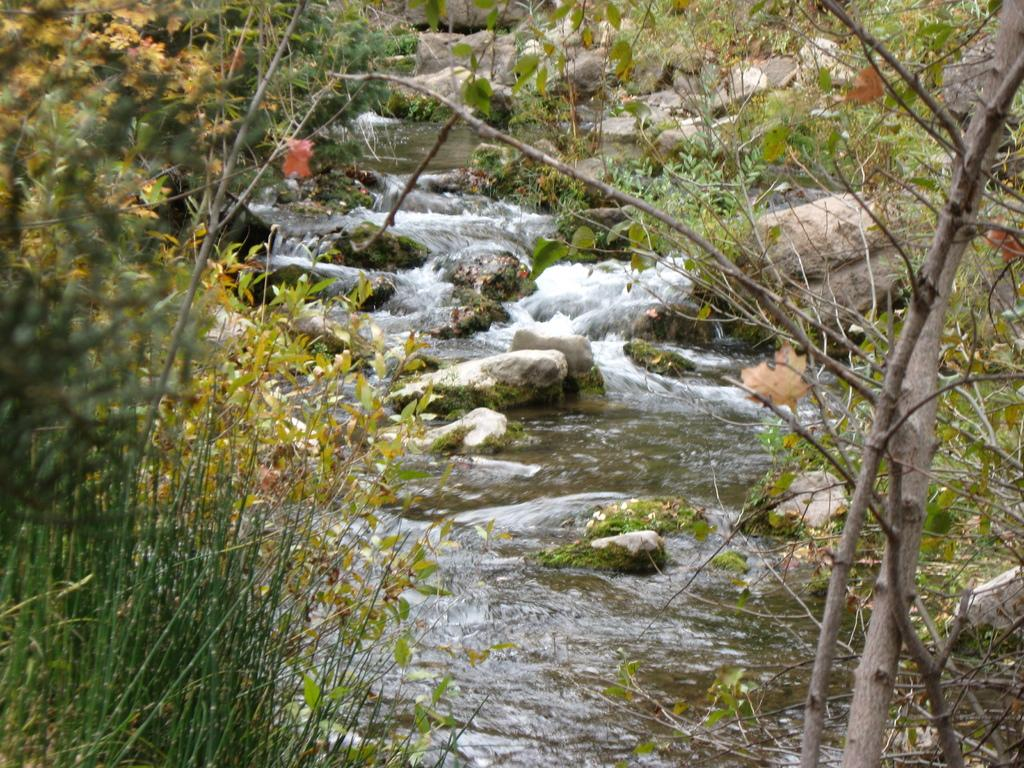What type of natural environment is depicted in the image? The image features many trees and plants, suggesting a natural setting. Can you describe the water visible in the image? Yes, there is water visible in the image. What other elements can be seen in the image? There are big stones in the image. What type of advice is being given in the image? There is no indication of any advice being given in the image; it primarily features trees, plants, water, and big stones. What color is the skirt worn by the person in the image? There is no person wearing a skirt present in the image. 